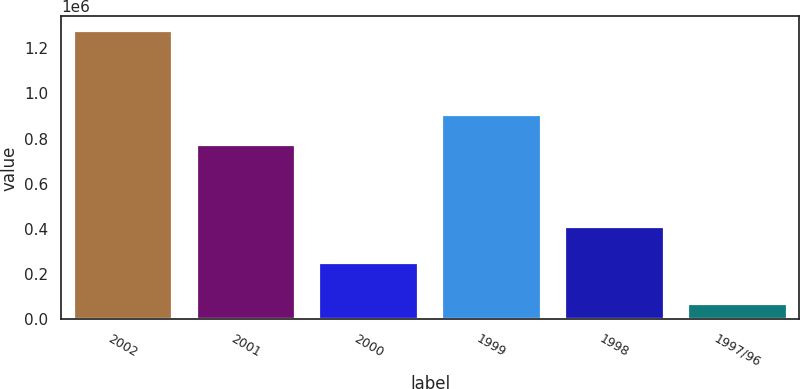Convert chart to OTSL. <chart><loc_0><loc_0><loc_500><loc_500><bar_chart><fcel>2002<fcel>2001<fcel>2000<fcel>1999<fcel>1998<fcel>1997/96<nl><fcel>1.27655e+06<fcel>772550<fcel>249050<fcel>905650<fcel>409050<fcel>67401<nl></chart> 